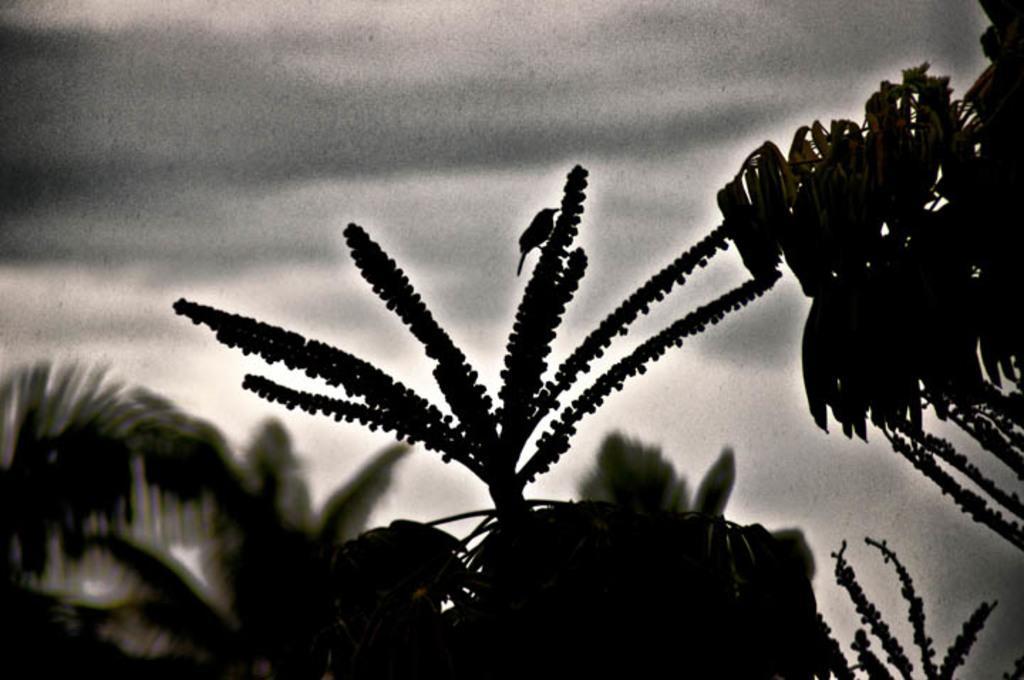Can you describe this image briefly? It is a black and white image, at the bottom there are trees and at the top it is the sky. 